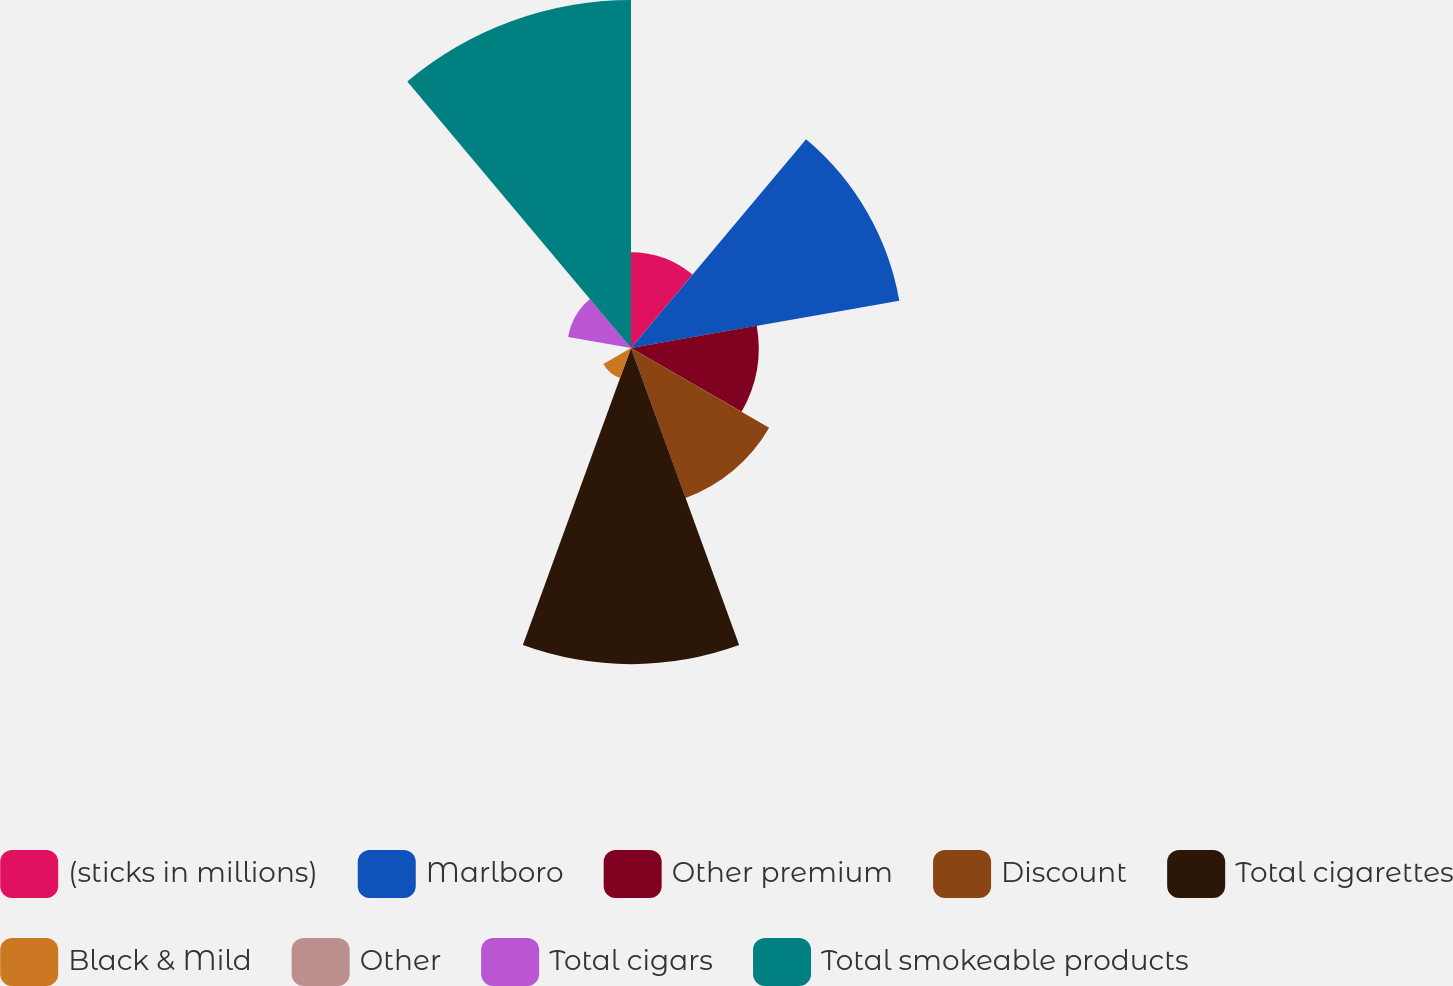Convert chart. <chart><loc_0><loc_0><loc_500><loc_500><pie_chart><fcel>(sticks in millions)<fcel>Marlboro<fcel>Other premium<fcel>Discount<fcel>Total cigarettes<fcel>Black & Mild<fcel>Other<fcel>Total cigars<fcel>Total smokeable products<nl><fcel>6.77%<fcel>19.25%<fcel>9.02%<fcel>11.27%<fcel>22.34%<fcel>2.26%<fcel>0.0%<fcel>4.51%<fcel>24.59%<nl></chart> 